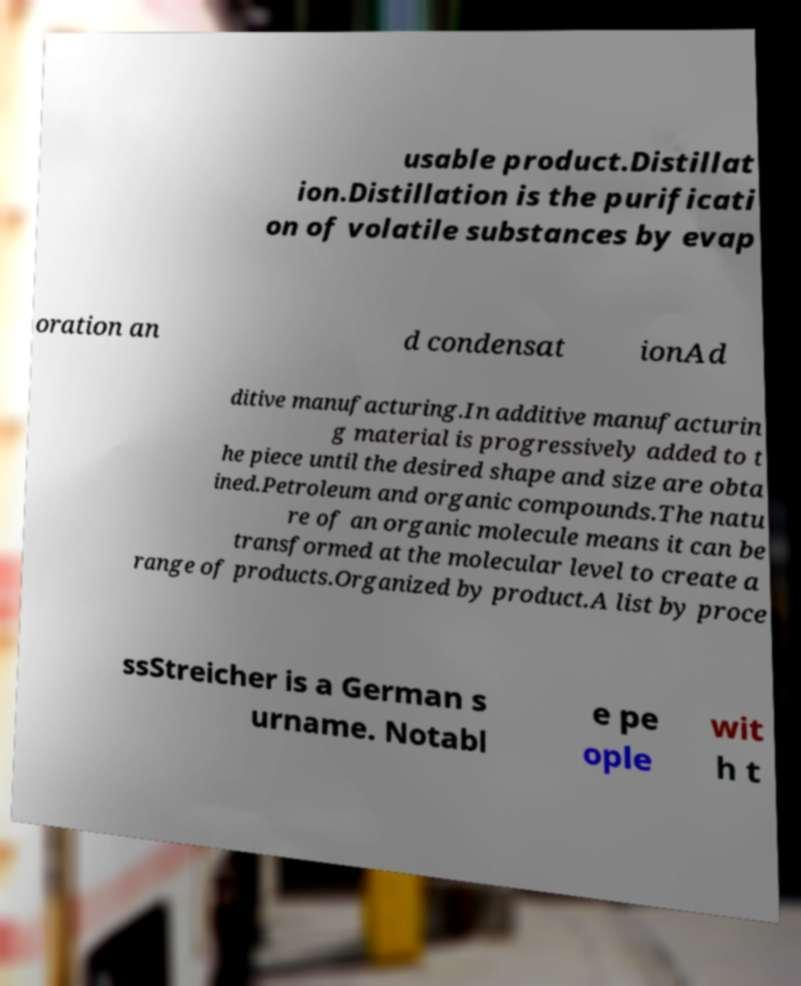Please identify and transcribe the text found in this image. usable product.Distillat ion.Distillation is the purificati on of volatile substances by evap oration an d condensat ionAd ditive manufacturing.In additive manufacturin g material is progressively added to t he piece until the desired shape and size are obta ined.Petroleum and organic compounds.The natu re of an organic molecule means it can be transformed at the molecular level to create a range of products.Organized by product.A list by proce ssStreicher is a German s urname. Notabl e pe ople wit h t 